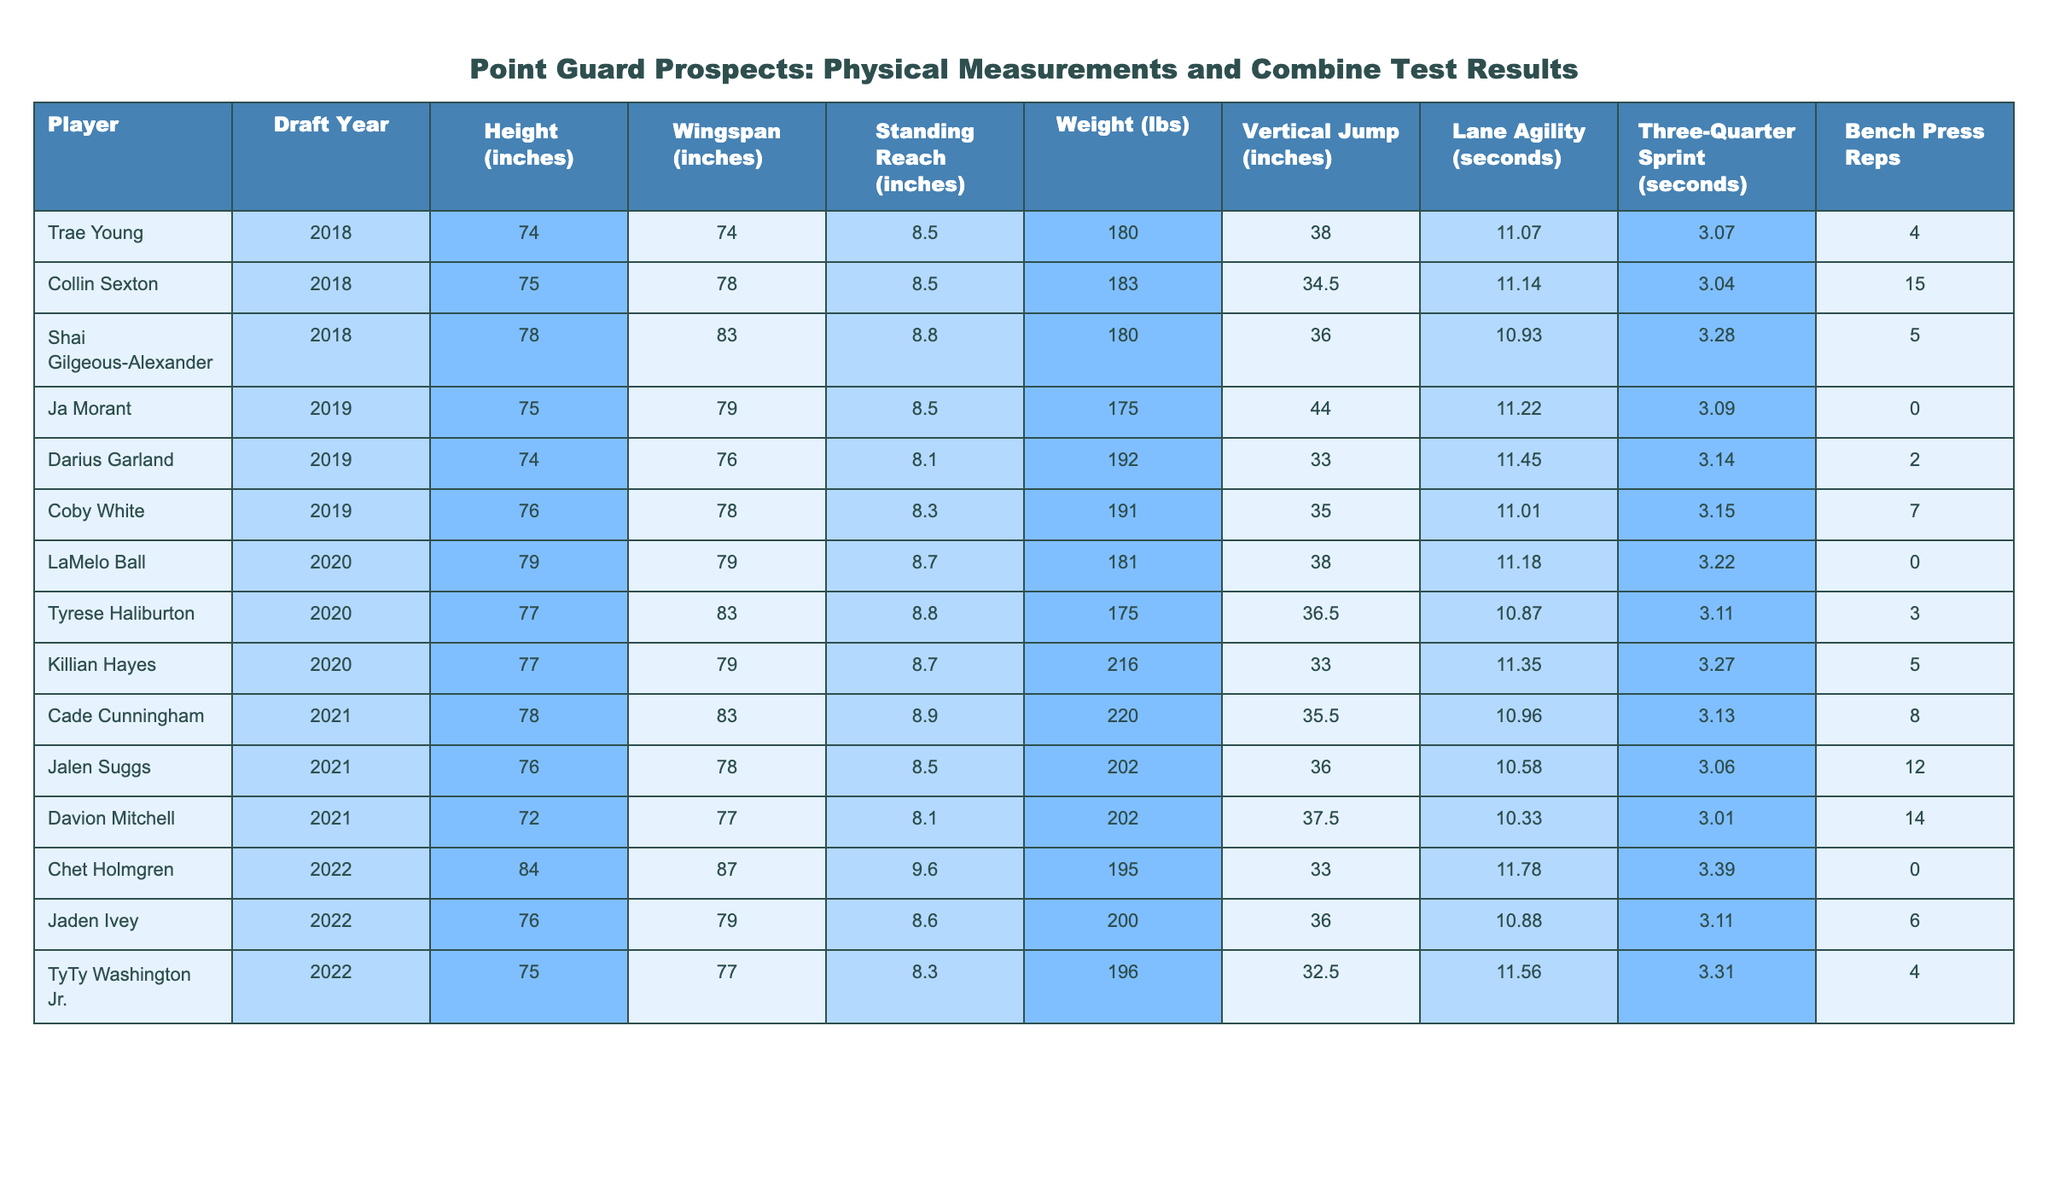What is the height of Ja Morant? Ja Morant's height can be found in the table under the "Height (inches)" column for the row corresponding to his name. The value is 75 inches.
Answer: 75 inches Which player has the longest wingspan? By reviewing the "Wingspan (inches)" column, we can see that Chet Holmgren has the longest wingspan at 87 inches.
Answer: Chet Holmgren What is the average weight of the players in the table? To find the average weight, sum all the weights: (180 + 183 + 180 + 175 + 192 + 191 + 181 + 175 + 216 + 220 + 202 + 195 + 200 + 196) =  2536. There are 14 players, so the average weight is 2536/14 = 181.14 lbs.
Answer: 181.14 lbs Is there a player who bench pressed more than 10 times? By scanning the "Bench Press Reps" column, we find that there are players with values greater than 10. For instance, Collin Sexton (15) and Davion Mitchell (14) both bench pressed more than 10 times.
Answer: Yes What is the difference in vertical jump inches between LaMelo Ball and Ja Morant? LaMelo Ball's vertical jump is 38 inches, and Ja Morant's is 44 inches. The difference is 44 - 38 = 6 inches.
Answer: 6 inches Who has the highest lane agility time among the players? Checking the "Lane Agility (seconds)" column, we find that Darius Garland has the highest lane agility time at 11.45 seconds.
Answer: Darius Garland Which player has the lowest standing reach? Looking at the "Standing Reach (inches)" column, the lowest value belongs to Darius Garland, who has a standing reach of 8.1 inches.
Answer: Darius Garland What is the median weight of the players? First, we list the weights in ascending order: 175, 180, 180, 181, 183, 191, 192, 195, 196, 200, 202, 220, 216. With 14 players, the median will be the average of the 7th and 8th values: (192 + 195)/2 = 193.5 lbs.
Answer: 193.5 lbs Is Killian Hayes taller than Tyrese Haliburton? Comparing their heights, Killian Hayes at 77 inches is equal to Tyrese Haliburton, who is also 77 inches tall. Therefore, Killian Hayes is not taller.
Answer: No Which player had the best sprint time? By looking at the "Three-Quarter Sprint (seconds)" column, the quickest time is found with Davion Mitchell at 3.01 seconds, indicating he had the best sprint time.
Answer: Davion Mitchell 